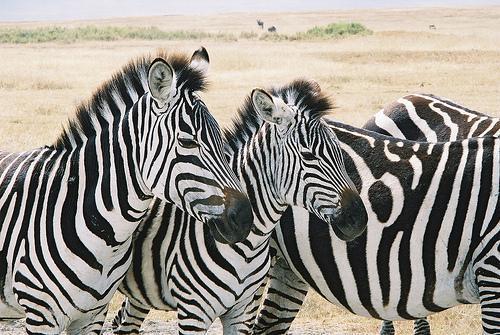How many zebra heads can you see?
Give a very brief answer. 2. How many zebras are there?
Give a very brief answer. 4. 